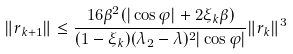Convert formula to latex. <formula><loc_0><loc_0><loc_500><loc_500>\| r _ { k + 1 } \| \leq \frac { 1 6 \beta ^ { 2 } ( | \cos \varphi | + 2 \xi _ { k } \beta ) } { ( 1 - \xi _ { k } ) ( \lambda _ { 2 } - \lambda ) ^ { 2 } | \cos \varphi | } \| r _ { k } \| ^ { 3 }</formula> 